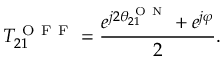Convert formula to latex. <formula><loc_0><loc_0><loc_500><loc_500>T _ { 2 1 } ^ { O F F } = \frac { e ^ { j 2 \theta _ { 2 1 } ^ { O N } } + e ^ { j \varphi } } { 2 } .</formula> 